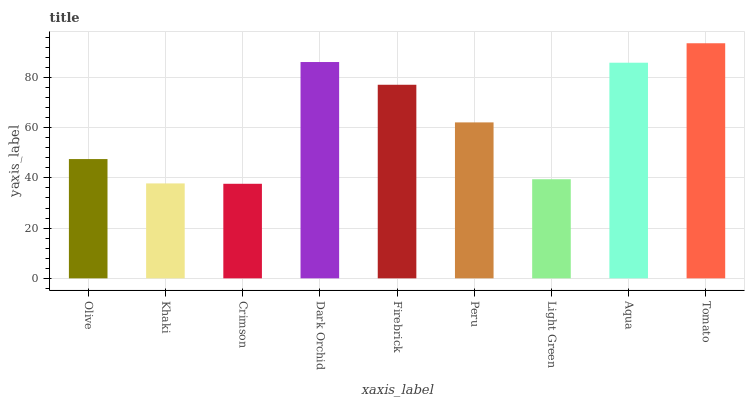Is Crimson the minimum?
Answer yes or no. Yes. Is Tomato the maximum?
Answer yes or no. Yes. Is Khaki the minimum?
Answer yes or no. No. Is Khaki the maximum?
Answer yes or no. No. Is Olive greater than Khaki?
Answer yes or no. Yes. Is Khaki less than Olive?
Answer yes or no. Yes. Is Khaki greater than Olive?
Answer yes or no. No. Is Olive less than Khaki?
Answer yes or no. No. Is Peru the high median?
Answer yes or no. Yes. Is Peru the low median?
Answer yes or no. Yes. Is Olive the high median?
Answer yes or no. No. Is Dark Orchid the low median?
Answer yes or no. No. 